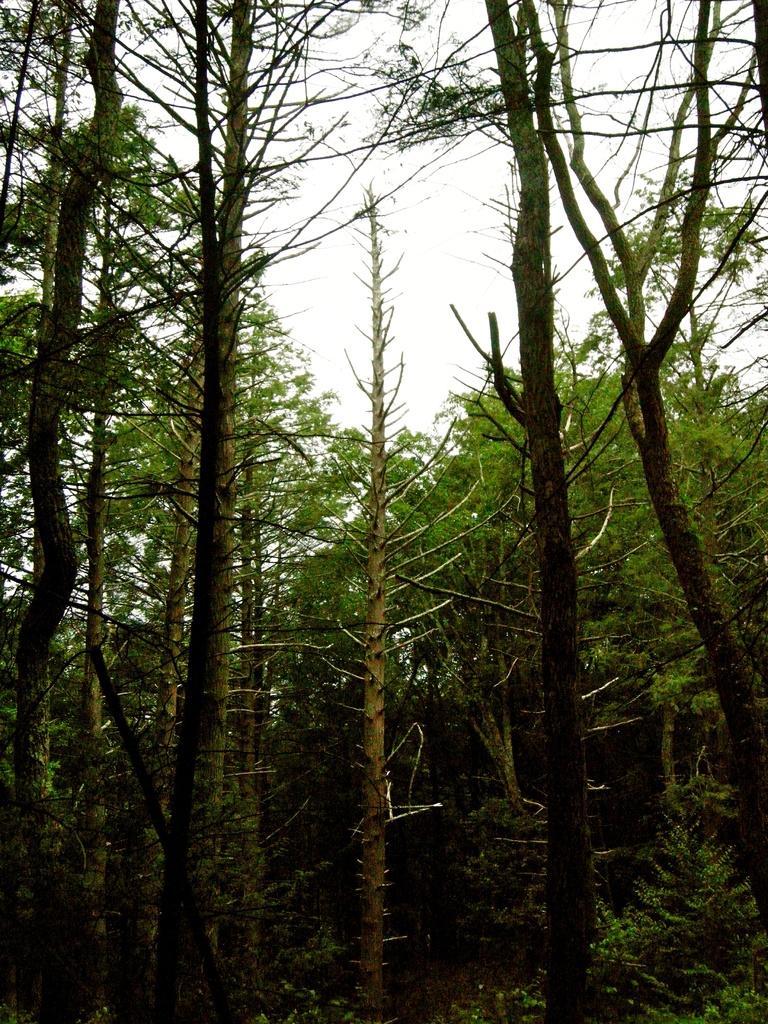In one or two sentences, can you explain what this image depicts? There are trees in the foreground area of the image and the sky in the background. 